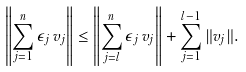<formula> <loc_0><loc_0><loc_500><loc_500>\left \| \sum _ { j = 1 } ^ { n } \epsilon _ { j } \, v _ { j } \right \| \leq \left \| \sum _ { j = l } ^ { n } \epsilon _ { j } \, v _ { j } \right \| + \sum _ { j = 1 } ^ { l - 1 } \| v _ { j } \| .</formula> 